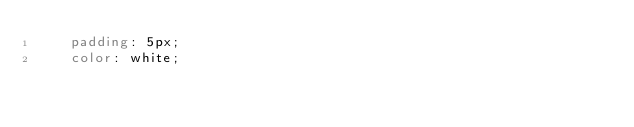<code> <loc_0><loc_0><loc_500><loc_500><_CSS_>    padding: 5px;
    color: white;</code> 